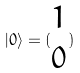Convert formula to latex. <formula><loc_0><loc_0><loc_500><loc_500>| 0 \rangle = ( \begin{matrix} 1 \\ 0 \end{matrix} )</formula> 